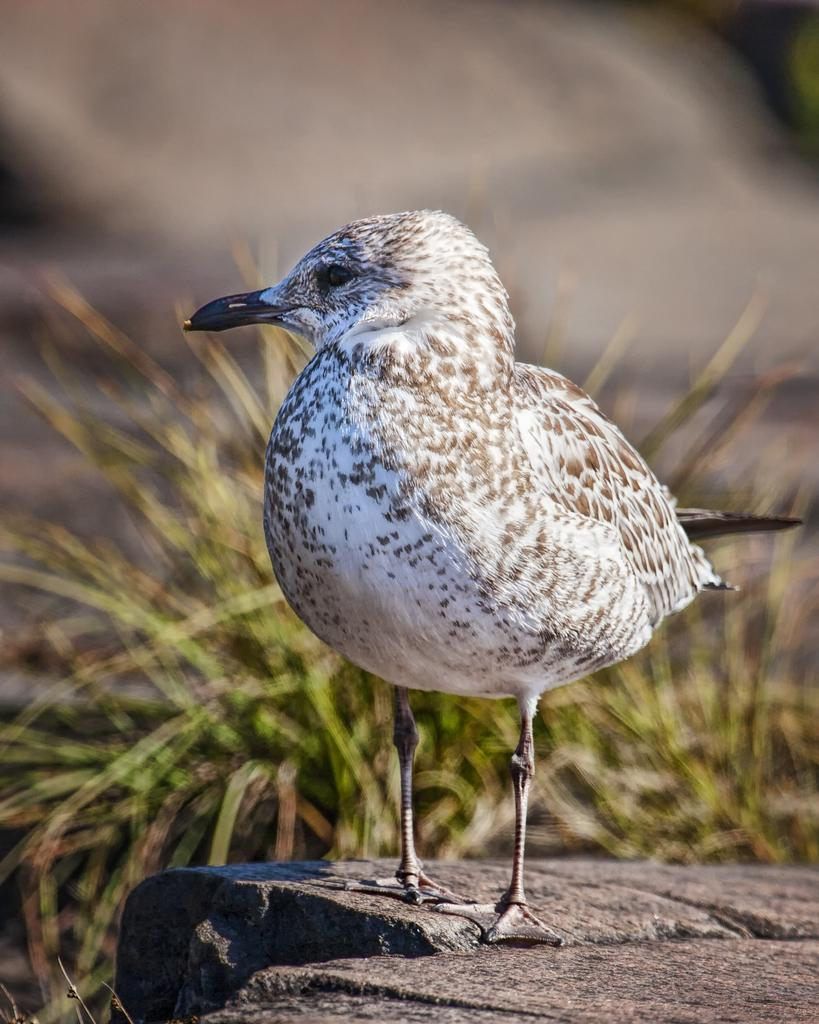What type of animal can be seen in the image? There is a bird in the image. Where is the bird located? The bird is standing on a rock. What type of vegetation is visible in the image? There is grass visible in the image. How would you describe the background of the image? The background of the image is blurry. What idea does the bird have about the history of the bottle in the image? There is no bottle present in the image, and therefore no such interaction or idea can be observed. 